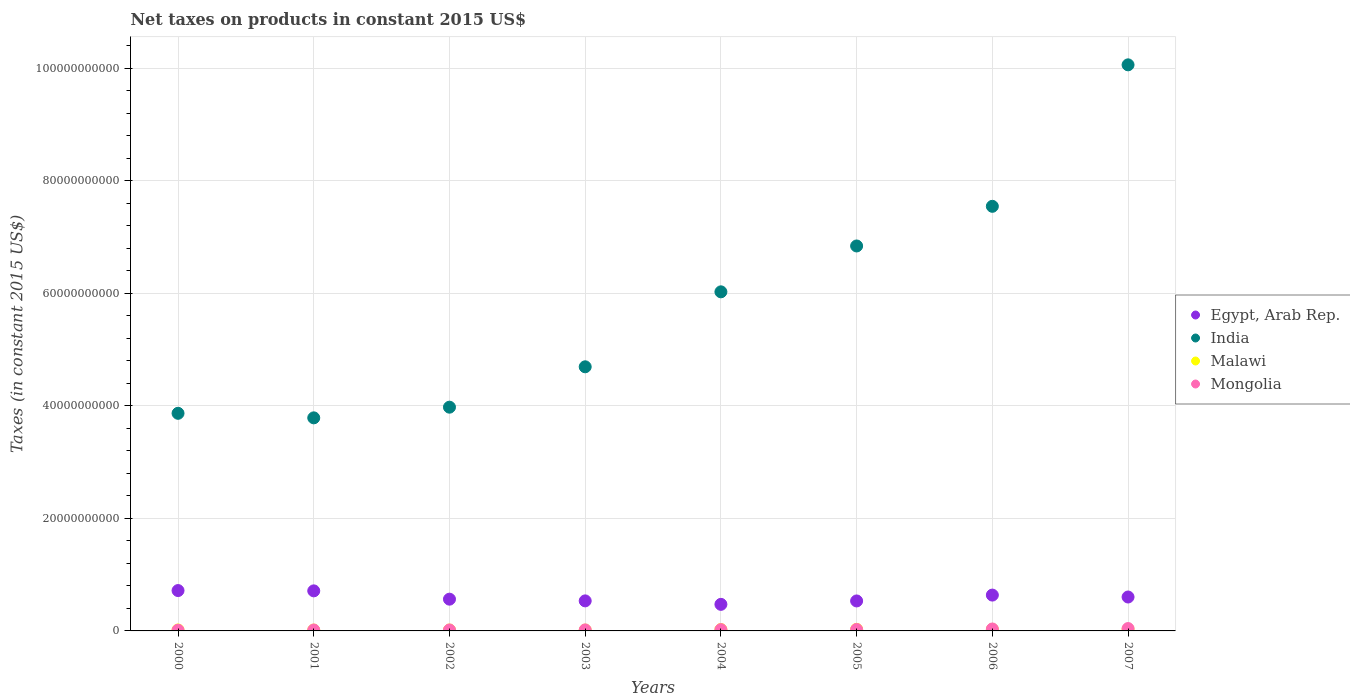How many different coloured dotlines are there?
Make the answer very short. 4. What is the net taxes on products in Malawi in 2005?
Make the answer very short. 2.83e+08. Across all years, what is the maximum net taxes on products in Malawi?
Offer a very short reply. 3.02e+08. Across all years, what is the minimum net taxes on products in Egypt, Arab Rep.?
Give a very brief answer. 4.72e+09. In which year was the net taxes on products in Egypt, Arab Rep. minimum?
Give a very brief answer. 2004. What is the total net taxes on products in Mongolia in the graph?
Give a very brief answer. 1.89e+09. What is the difference between the net taxes on products in Malawi in 2000 and that in 2001?
Make the answer very short. 1.61e+07. What is the difference between the net taxes on products in Egypt, Arab Rep. in 2003 and the net taxes on products in India in 2000?
Give a very brief answer. -3.33e+1. What is the average net taxes on products in Mongolia per year?
Make the answer very short. 2.36e+08. In the year 2002, what is the difference between the net taxes on products in Mongolia and net taxes on products in Malawi?
Provide a short and direct response. 6.00e+06. In how many years, is the net taxes on products in Mongolia greater than 60000000000 US$?
Your answer should be very brief. 0. What is the ratio of the net taxes on products in Mongolia in 2000 to that in 2007?
Give a very brief answer. 0.3. Is the net taxes on products in Mongolia in 2001 less than that in 2004?
Provide a succinct answer. Yes. What is the difference between the highest and the second highest net taxes on products in Mongolia?
Your response must be concise. 7.67e+07. What is the difference between the highest and the lowest net taxes on products in Malawi?
Make the answer very short. 1.51e+08. Is the sum of the net taxes on products in Malawi in 2002 and 2003 greater than the maximum net taxes on products in Egypt, Arab Rep. across all years?
Offer a terse response. No. Is it the case that in every year, the sum of the net taxes on products in India and net taxes on products in Malawi  is greater than the net taxes on products in Egypt, Arab Rep.?
Offer a very short reply. Yes. Does the net taxes on products in India monotonically increase over the years?
Provide a succinct answer. No. Does the graph contain grids?
Give a very brief answer. Yes. What is the title of the graph?
Provide a succinct answer. Net taxes on products in constant 2015 US$. Does "French Polynesia" appear as one of the legend labels in the graph?
Make the answer very short. No. What is the label or title of the Y-axis?
Your response must be concise. Taxes (in constant 2015 US$). What is the Taxes (in constant 2015 US$) of Egypt, Arab Rep. in 2000?
Keep it short and to the point. 7.17e+09. What is the Taxes (in constant 2015 US$) of India in 2000?
Your answer should be compact. 3.87e+1. What is the Taxes (in constant 2015 US$) of Malawi in 2000?
Provide a succinct answer. 1.71e+08. What is the Taxes (in constant 2015 US$) in Mongolia in 2000?
Your answer should be very brief. 1.27e+08. What is the Taxes (in constant 2015 US$) of Egypt, Arab Rep. in 2001?
Make the answer very short. 7.12e+09. What is the Taxes (in constant 2015 US$) in India in 2001?
Provide a succinct answer. 3.79e+1. What is the Taxes (in constant 2015 US$) of Malawi in 2001?
Ensure brevity in your answer.  1.55e+08. What is the Taxes (in constant 2015 US$) in Mongolia in 2001?
Give a very brief answer. 1.63e+08. What is the Taxes (in constant 2015 US$) in Egypt, Arab Rep. in 2002?
Your answer should be very brief. 5.64e+09. What is the Taxes (in constant 2015 US$) in India in 2002?
Make the answer very short. 3.98e+1. What is the Taxes (in constant 2015 US$) in Malawi in 2002?
Give a very brief answer. 1.62e+08. What is the Taxes (in constant 2015 US$) of Mongolia in 2002?
Offer a very short reply. 1.68e+08. What is the Taxes (in constant 2015 US$) in Egypt, Arab Rep. in 2003?
Offer a terse response. 5.34e+09. What is the Taxes (in constant 2015 US$) in India in 2003?
Give a very brief answer. 4.69e+1. What is the Taxes (in constant 2015 US$) in Malawi in 2003?
Provide a short and direct response. 1.52e+08. What is the Taxes (in constant 2015 US$) in Mongolia in 2003?
Provide a succinct answer. 1.78e+08. What is the Taxes (in constant 2015 US$) in Egypt, Arab Rep. in 2004?
Offer a very short reply. 4.72e+09. What is the Taxes (in constant 2015 US$) of India in 2004?
Give a very brief answer. 6.03e+1. What is the Taxes (in constant 2015 US$) of Malawi in 2004?
Ensure brevity in your answer.  2.44e+08. What is the Taxes (in constant 2015 US$) in Mongolia in 2004?
Make the answer very short. 2.27e+08. What is the Taxes (in constant 2015 US$) of Egypt, Arab Rep. in 2005?
Your response must be concise. 5.33e+09. What is the Taxes (in constant 2015 US$) of India in 2005?
Your answer should be compact. 6.84e+1. What is the Taxes (in constant 2015 US$) of Malawi in 2005?
Provide a succinct answer. 2.83e+08. What is the Taxes (in constant 2015 US$) of Mongolia in 2005?
Give a very brief answer. 2.59e+08. What is the Taxes (in constant 2015 US$) in Egypt, Arab Rep. in 2006?
Make the answer very short. 6.37e+09. What is the Taxes (in constant 2015 US$) of India in 2006?
Provide a succinct answer. 7.55e+1. What is the Taxes (in constant 2015 US$) of Malawi in 2006?
Your answer should be very brief. 2.82e+08. What is the Taxes (in constant 2015 US$) of Mongolia in 2006?
Your answer should be very brief. 3.44e+08. What is the Taxes (in constant 2015 US$) in Egypt, Arab Rep. in 2007?
Make the answer very short. 6.03e+09. What is the Taxes (in constant 2015 US$) in India in 2007?
Your response must be concise. 1.01e+11. What is the Taxes (in constant 2015 US$) in Malawi in 2007?
Offer a very short reply. 3.02e+08. What is the Taxes (in constant 2015 US$) in Mongolia in 2007?
Keep it short and to the point. 4.20e+08. Across all years, what is the maximum Taxes (in constant 2015 US$) of Egypt, Arab Rep.?
Your response must be concise. 7.17e+09. Across all years, what is the maximum Taxes (in constant 2015 US$) in India?
Provide a short and direct response. 1.01e+11. Across all years, what is the maximum Taxes (in constant 2015 US$) of Malawi?
Offer a very short reply. 3.02e+08. Across all years, what is the maximum Taxes (in constant 2015 US$) of Mongolia?
Offer a very short reply. 4.20e+08. Across all years, what is the minimum Taxes (in constant 2015 US$) in Egypt, Arab Rep.?
Keep it short and to the point. 4.72e+09. Across all years, what is the minimum Taxes (in constant 2015 US$) of India?
Provide a short and direct response. 3.79e+1. Across all years, what is the minimum Taxes (in constant 2015 US$) in Malawi?
Ensure brevity in your answer.  1.52e+08. Across all years, what is the minimum Taxes (in constant 2015 US$) in Mongolia?
Make the answer very short. 1.27e+08. What is the total Taxes (in constant 2015 US$) in Egypt, Arab Rep. in the graph?
Provide a succinct answer. 4.77e+1. What is the total Taxes (in constant 2015 US$) of India in the graph?
Provide a short and direct response. 4.68e+11. What is the total Taxes (in constant 2015 US$) of Malawi in the graph?
Your answer should be very brief. 1.75e+09. What is the total Taxes (in constant 2015 US$) of Mongolia in the graph?
Your answer should be very brief. 1.89e+09. What is the difference between the Taxes (in constant 2015 US$) in Egypt, Arab Rep. in 2000 and that in 2001?
Make the answer very short. 5.32e+07. What is the difference between the Taxes (in constant 2015 US$) in India in 2000 and that in 2001?
Make the answer very short. 8.07e+08. What is the difference between the Taxes (in constant 2015 US$) of Malawi in 2000 and that in 2001?
Keep it short and to the point. 1.61e+07. What is the difference between the Taxes (in constant 2015 US$) in Mongolia in 2000 and that in 2001?
Give a very brief answer. -3.56e+07. What is the difference between the Taxes (in constant 2015 US$) in Egypt, Arab Rep. in 2000 and that in 2002?
Your answer should be compact. 1.53e+09. What is the difference between the Taxes (in constant 2015 US$) of India in 2000 and that in 2002?
Offer a very short reply. -1.09e+09. What is the difference between the Taxes (in constant 2015 US$) of Malawi in 2000 and that in 2002?
Your answer should be compact. 9.42e+06. What is the difference between the Taxes (in constant 2015 US$) of Mongolia in 2000 and that in 2002?
Provide a short and direct response. -4.05e+07. What is the difference between the Taxes (in constant 2015 US$) in Egypt, Arab Rep. in 2000 and that in 2003?
Your answer should be very brief. 1.83e+09. What is the difference between the Taxes (in constant 2015 US$) in India in 2000 and that in 2003?
Ensure brevity in your answer.  -8.27e+09. What is the difference between the Taxes (in constant 2015 US$) in Malawi in 2000 and that in 2003?
Offer a very short reply. 1.94e+07. What is the difference between the Taxes (in constant 2015 US$) of Mongolia in 2000 and that in 2003?
Provide a succinct answer. -5.13e+07. What is the difference between the Taxes (in constant 2015 US$) in Egypt, Arab Rep. in 2000 and that in 2004?
Your response must be concise. 2.45e+09. What is the difference between the Taxes (in constant 2015 US$) of India in 2000 and that in 2004?
Provide a short and direct response. -2.16e+1. What is the difference between the Taxes (in constant 2015 US$) in Malawi in 2000 and that in 2004?
Make the answer very short. -7.26e+07. What is the difference between the Taxes (in constant 2015 US$) of Mongolia in 2000 and that in 2004?
Your answer should be compact. -1.00e+08. What is the difference between the Taxes (in constant 2015 US$) of Egypt, Arab Rep. in 2000 and that in 2005?
Provide a short and direct response. 1.84e+09. What is the difference between the Taxes (in constant 2015 US$) in India in 2000 and that in 2005?
Make the answer very short. -2.97e+1. What is the difference between the Taxes (in constant 2015 US$) in Malawi in 2000 and that in 2005?
Your response must be concise. -1.12e+08. What is the difference between the Taxes (in constant 2015 US$) of Mongolia in 2000 and that in 2005?
Keep it short and to the point. -1.32e+08. What is the difference between the Taxes (in constant 2015 US$) in Egypt, Arab Rep. in 2000 and that in 2006?
Ensure brevity in your answer.  8.04e+08. What is the difference between the Taxes (in constant 2015 US$) in India in 2000 and that in 2006?
Offer a terse response. -3.68e+1. What is the difference between the Taxes (in constant 2015 US$) in Malawi in 2000 and that in 2006?
Your answer should be very brief. -1.11e+08. What is the difference between the Taxes (in constant 2015 US$) in Mongolia in 2000 and that in 2006?
Make the answer very short. -2.16e+08. What is the difference between the Taxes (in constant 2015 US$) of Egypt, Arab Rep. in 2000 and that in 2007?
Your answer should be very brief. 1.15e+09. What is the difference between the Taxes (in constant 2015 US$) in India in 2000 and that in 2007?
Offer a terse response. -6.19e+1. What is the difference between the Taxes (in constant 2015 US$) of Malawi in 2000 and that in 2007?
Your response must be concise. -1.31e+08. What is the difference between the Taxes (in constant 2015 US$) of Mongolia in 2000 and that in 2007?
Your response must be concise. -2.93e+08. What is the difference between the Taxes (in constant 2015 US$) in Egypt, Arab Rep. in 2001 and that in 2002?
Offer a very short reply. 1.48e+09. What is the difference between the Taxes (in constant 2015 US$) in India in 2001 and that in 2002?
Your response must be concise. -1.90e+09. What is the difference between the Taxes (in constant 2015 US$) of Malawi in 2001 and that in 2002?
Make the answer very short. -6.73e+06. What is the difference between the Taxes (in constant 2015 US$) of Mongolia in 2001 and that in 2002?
Keep it short and to the point. -4.89e+06. What is the difference between the Taxes (in constant 2015 US$) of Egypt, Arab Rep. in 2001 and that in 2003?
Your answer should be compact. 1.78e+09. What is the difference between the Taxes (in constant 2015 US$) in India in 2001 and that in 2003?
Ensure brevity in your answer.  -9.07e+09. What is the difference between the Taxes (in constant 2015 US$) of Malawi in 2001 and that in 2003?
Provide a short and direct response. 3.26e+06. What is the difference between the Taxes (in constant 2015 US$) of Mongolia in 2001 and that in 2003?
Make the answer very short. -1.57e+07. What is the difference between the Taxes (in constant 2015 US$) of Egypt, Arab Rep. in 2001 and that in 2004?
Provide a short and direct response. 2.40e+09. What is the difference between the Taxes (in constant 2015 US$) in India in 2001 and that in 2004?
Your answer should be compact. -2.24e+1. What is the difference between the Taxes (in constant 2015 US$) in Malawi in 2001 and that in 2004?
Your answer should be very brief. -8.88e+07. What is the difference between the Taxes (in constant 2015 US$) in Mongolia in 2001 and that in 2004?
Your answer should be compact. -6.44e+07. What is the difference between the Taxes (in constant 2015 US$) in Egypt, Arab Rep. in 2001 and that in 2005?
Keep it short and to the point. 1.79e+09. What is the difference between the Taxes (in constant 2015 US$) of India in 2001 and that in 2005?
Provide a succinct answer. -3.05e+1. What is the difference between the Taxes (in constant 2015 US$) in Malawi in 2001 and that in 2005?
Keep it short and to the point. -1.28e+08. What is the difference between the Taxes (in constant 2015 US$) of Mongolia in 2001 and that in 2005?
Offer a terse response. -9.59e+07. What is the difference between the Taxes (in constant 2015 US$) of Egypt, Arab Rep. in 2001 and that in 2006?
Ensure brevity in your answer.  7.51e+08. What is the difference between the Taxes (in constant 2015 US$) in India in 2001 and that in 2006?
Your response must be concise. -3.76e+1. What is the difference between the Taxes (in constant 2015 US$) of Malawi in 2001 and that in 2006?
Your response must be concise. -1.27e+08. What is the difference between the Taxes (in constant 2015 US$) in Mongolia in 2001 and that in 2006?
Make the answer very short. -1.81e+08. What is the difference between the Taxes (in constant 2015 US$) of Egypt, Arab Rep. in 2001 and that in 2007?
Your response must be concise. 1.09e+09. What is the difference between the Taxes (in constant 2015 US$) in India in 2001 and that in 2007?
Make the answer very short. -6.27e+1. What is the difference between the Taxes (in constant 2015 US$) in Malawi in 2001 and that in 2007?
Provide a short and direct response. -1.47e+08. What is the difference between the Taxes (in constant 2015 US$) in Mongolia in 2001 and that in 2007?
Your answer should be very brief. -2.58e+08. What is the difference between the Taxes (in constant 2015 US$) of Egypt, Arab Rep. in 2002 and that in 2003?
Provide a short and direct response. 3.03e+08. What is the difference between the Taxes (in constant 2015 US$) in India in 2002 and that in 2003?
Ensure brevity in your answer.  -7.18e+09. What is the difference between the Taxes (in constant 2015 US$) in Malawi in 2002 and that in 2003?
Provide a short and direct response. 9.99e+06. What is the difference between the Taxes (in constant 2015 US$) in Mongolia in 2002 and that in 2003?
Provide a succinct answer. -1.08e+07. What is the difference between the Taxes (in constant 2015 US$) of Egypt, Arab Rep. in 2002 and that in 2004?
Your answer should be very brief. 9.22e+08. What is the difference between the Taxes (in constant 2015 US$) in India in 2002 and that in 2004?
Your answer should be very brief. -2.05e+1. What is the difference between the Taxes (in constant 2015 US$) in Malawi in 2002 and that in 2004?
Provide a succinct answer. -8.21e+07. What is the difference between the Taxes (in constant 2015 US$) in Mongolia in 2002 and that in 2004?
Your answer should be compact. -5.95e+07. What is the difference between the Taxes (in constant 2015 US$) in Egypt, Arab Rep. in 2002 and that in 2005?
Your response must be concise. 3.15e+08. What is the difference between the Taxes (in constant 2015 US$) in India in 2002 and that in 2005?
Keep it short and to the point. -2.86e+1. What is the difference between the Taxes (in constant 2015 US$) of Malawi in 2002 and that in 2005?
Ensure brevity in your answer.  -1.21e+08. What is the difference between the Taxes (in constant 2015 US$) in Mongolia in 2002 and that in 2005?
Give a very brief answer. -9.10e+07. What is the difference between the Taxes (in constant 2015 US$) of Egypt, Arab Rep. in 2002 and that in 2006?
Make the answer very short. -7.26e+08. What is the difference between the Taxes (in constant 2015 US$) of India in 2002 and that in 2006?
Keep it short and to the point. -3.57e+1. What is the difference between the Taxes (in constant 2015 US$) of Malawi in 2002 and that in 2006?
Make the answer very short. -1.20e+08. What is the difference between the Taxes (in constant 2015 US$) of Mongolia in 2002 and that in 2006?
Make the answer very short. -1.76e+08. What is the difference between the Taxes (in constant 2015 US$) of Egypt, Arab Rep. in 2002 and that in 2007?
Offer a very short reply. -3.84e+08. What is the difference between the Taxes (in constant 2015 US$) in India in 2002 and that in 2007?
Your answer should be compact. -6.08e+1. What is the difference between the Taxes (in constant 2015 US$) in Malawi in 2002 and that in 2007?
Give a very brief answer. -1.41e+08. What is the difference between the Taxes (in constant 2015 US$) of Mongolia in 2002 and that in 2007?
Ensure brevity in your answer.  -2.53e+08. What is the difference between the Taxes (in constant 2015 US$) of Egypt, Arab Rep. in 2003 and that in 2004?
Your answer should be very brief. 6.19e+08. What is the difference between the Taxes (in constant 2015 US$) of India in 2003 and that in 2004?
Offer a terse response. -1.33e+1. What is the difference between the Taxes (in constant 2015 US$) in Malawi in 2003 and that in 2004?
Your answer should be compact. -9.20e+07. What is the difference between the Taxes (in constant 2015 US$) of Mongolia in 2003 and that in 2004?
Ensure brevity in your answer.  -4.87e+07. What is the difference between the Taxes (in constant 2015 US$) in Egypt, Arab Rep. in 2003 and that in 2005?
Make the answer very short. 1.14e+07. What is the difference between the Taxes (in constant 2015 US$) of India in 2003 and that in 2005?
Provide a succinct answer. -2.15e+1. What is the difference between the Taxes (in constant 2015 US$) of Malawi in 2003 and that in 2005?
Keep it short and to the point. -1.31e+08. What is the difference between the Taxes (in constant 2015 US$) in Mongolia in 2003 and that in 2005?
Provide a short and direct response. -8.02e+07. What is the difference between the Taxes (in constant 2015 US$) of Egypt, Arab Rep. in 2003 and that in 2006?
Make the answer very short. -1.03e+09. What is the difference between the Taxes (in constant 2015 US$) of India in 2003 and that in 2006?
Offer a very short reply. -2.85e+1. What is the difference between the Taxes (in constant 2015 US$) of Malawi in 2003 and that in 2006?
Provide a short and direct response. -1.30e+08. What is the difference between the Taxes (in constant 2015 US$) in Mongolia in 2003 and that in 2006?
Ensure brevity in your answer.  -1.65e+08. What is the difference between the Taxes (in constant 2015 US$) of Egypt, Arab Rep. in 2003 and that in 2007?
Your response must be concise. -6.87e+08. What is the difference between the Taxes (in constant 2015 US$) in India in 2003 and that in 2007?
Your answer should be compact. -5.37e+1. What is the difference between the Taxes (in constant 2015 US$) of Malawi in 2003 and that in 2007?
Provide a succinct answer. -1.51e+08. What is the difference between the Taxes (in constant 2015 US$) of Mongolia in 2003 and that in 2007?
Your answer should be compact. -2.42e+08. What is the difference between the Taxes (in constant 2015 US$) of Egypt, Arab Rep. in 2004 and that in 2005?
Ensure brevity in your answer.  -6.07e+08. What is the difference between the Taxes (in constant 2015 US$) in India in 2004 and that in 2005?
Make the answer very short. -8.15e+09. What is the difference between the Taxes (in constant 2015 US$) of Malawi in 2004 and that in 2005?
Give a very brief answer. -3.90e+07. What is the difference between the Taxes (in constant 2015 US$) in Mongolia in 2004 and that in 2005?
Provide a short and direct response. -3.15e+07. What is the difference between the Taxes (in constant 2015 US$) in Egypt, Arab Rep. in 2004 and that in 2006?
Your answer should be compact. -1.65e+09. What is the difference between the Taxes (in constant 2015 US$) in India in 2004 and that in 2006?
Give a very brief answer. -1.52e+1. What is the difference between the Taxes (in constant 2015 US$) in Malawi in 2004 and that in 2006?
Provide a short and direct response. -3.80e+07. What is the difference between the Taxes (in constant 2015 US$) of Mongolia in 2004 and that in 2006?
Ensure brevity in your answer.  -1.16e+08. What is the difference between the Taxes (in constant 2015 US$) of Egypt, Arab Rep. in 2004 and that in 2007?
Offer a terse response. -1.31e+09. What is the difference between the Taxes (in constant 2015 US$) in India in 2004 and that in 2007?
Provide a succinct answer. -4.03e+1. What is the difference between the Taxes (in constant 2015 US$) in Malawi in 2004 and that in 2007?
Give a very brief answer. -5.85e+07. What is the difference between the Taxes (in constant 2015 US$) of Mongolia in 2004 and that in 2007?
Your answer should be very brief. -1.93e+08. What is the difference between the Taxes (in constant 2015 US$) of Egypt, Arab Rep. in 2005 and that in 2006?
Ensure brevity in your answer.  -1.04e+09. What is the difference between the Taxes (in constant 2015 US$) in India in 2005 and that in 2006?
Your answer should be compact. -7.05e+09. What is the difference between the Taxes (in constant 2015 US$) of Malawi in 2005 and that in 2006?
Offer a very short reply. 1.02e+06. What is the difference between the Taxes (in constant 2015 US$) of Mongolia in 2005 and that in 2006?
Your response must be concise. -8.49e+07. What is the difference between the Taxes (in constant 2015 US$) in Egypt, Arab Rep. in 2005 and that in 2007?
Provide a short and direct response. -6.99e+08. What is the difference between the Taxes (in constant 2015 US$) of India in 2005 and that in 2007?
Make the answer very short. -3.22e+1. What is the difference between the Taxes (in constant 2015 US$) in Malawi in 2005 and that in 2007?
Offer a very short reply. -1.95e+07. What is the difference between the Taxes (in constant 2015 US$) in Mongolia in 2005 and that in 2007?
Offer a very short reply. -1.62e+08. What is the difference between the Taxes (in constant 2015 US$) of Egypt, Arab Rep. in 2006 and that in 2007?
Your response must be concise. 3.42e+08. What is the difference between the Taxes (in constant 2015 US$) of India in 2006 and that in 2007?
Offer a very short reply. -2.51e+1. What is the difference between the Taxes (in constant 2015 US$) in Malawi in 2006 and that in 2007?
Your answer should be compact. -2.05e+07. What is the difference between the Taxes (in constant 2015 US$) of Mongolia in 2006 and that in 2007?
Make the answer very short. -7.67e+07. What is the difference between the Taxes (in constant 2015 US$) in Egypt, Arab Rep. in 2000 and the Taxes (in constant 2015 US$) in India in 2001?
Make the answer very short. -3.07e+1. What is the difference between the Taxes (in constant 2015 US$) in Egypt, Arab Rep. in 2000 and the Taxes (in constant 2015 US$) in Malawi in 2001?
Give a very brief answer. 7.02e+09. What is the difference between the Taxes (in constant 2015 US$) of Egypt, Arab Rep. in 2000 and the Taxes (in constant 2015 US$) of Mongolia in 2001?
Provide a short and direct response. 7.01e+09. What is the difference between the Taxes (in constant 2015 US$) of India in 2000 and the Taxes (in constant 2015 US$) of Malawi in 2001?
Offer a terse response. 3.85e+1. What is the difference between the Taxes (in constant 2015 US$) of India in 2000 and the Taxes (in constant 2015 US$) of Mongolia in 2001?
Your answer should be very brief. 3.85e+1. What is the difference between the Taxes (in constant 2015 US$) of Malawi in 2000 and the Taxes (in constant 2015 US$) of Mongolia in 2001?
Your answer should be very brief. 8.31e+06. What is the difference between the Taxes (in constant 2015 US$) in Egypt, Arab Rep. in 2000 and the Taxes (in constant 2015 US$) in India in 2002?
Give a very brief answer. -3.26e+1. What is the difference between the Taxes (in constant 2015 US$) of Egypt, Arab Rep. in 2000 and the Taxes (in constant 2015 US$) of Malawi in 2002?
Provide a succinct answer. 7.01e+09. What is the difference between the Taxes (in constant 2015 US$) in Egypt, Arab Rep. in 2000 and the Taxes (in constant 2015 US$) in Mongolia in 2002?
Give a very brief answer. 7.00e+09. What is the difference between the Taxes (in constant 2015 US$) of India in 2000 and the Taxes (in constant 2015 US$) of Malawi in 2002?
Offer a terse response. 3.85e+1. What is the difference between the Taxes (in constant 2015 US$) in India in 2000 and the Taxes (in constant 2015 US$) in Mongolia in 2002?
Provide a succinct answer. 3.85e+1. What is the difference between the Taxes (in constant 2015 US$) of Malawi in 2000 and the Taxes (in constant 2015 US$) of Mongolia in 2002?
Your answer should be compact. 3.42e+06. What is the difference between the Taxes (in constant 2015 US$) of Egypt, Arab Rep. in 2000 and the Taxes (in constant 2015 US$) of India in 2003?
Make the answer very short. -3.98e+1. What is the difference between the Taxes (in constant 2015 US$) of Egypt, Arab Rep. in 2000 and the Taxes (in constant 2015 US$) of Malawi in 2003?
Provide a succinct answer. 7.02e+09. What is the difference between the Taxes (in constant 2015 US$) in Egypt, Arab Rep. in 2000 and the Taxes (in constant 2015 US$) in Mongolia in 2003?
Ensure brevity in your answer.  6.99e+09. What is the difference between the Taxes (in constant 2015 US$) of India in 2000 and the Taxes (in constant 2015 US$) of Malawi in 2003?
Your answer should be very brief. 3.85e+1. What is the difference between the Taxes (in constant 2015 US$) of India in 2000 and the Taxes (in constant 2015 US$) of Mongolia in 2003?
Make the answer very short. 3.85e+1. What is the difference between the Taxes (in constant 2015 US$) of Malawi in 2000 and the Taxes (in constant 2015 US$) of Mongolia in 2003?
Make the answer very short. -7.42e+06. What is the difference between the Taxes (in constant 2015 US$) of Egypt, Arab Rep. in 2000 and the Taxes (in constant 2015 US$) of India in 2004?
Offer a terse response. -5.31e+1. What is the difference between the Taxes (in constant 2015 US$) in Egypt, Arab Rep. in 2000 and the Taxes (in constant 2015 US$) in Malawi in 2004?
Ensure brevity in your answer.  6.93e+09. What is the difference between the Taxes (in constant 2015 US$) in Egypt, Arab Rep. in 2000 and the Taxes (in constant 2015 US$) in Mongolia in 2004?
Provide a succinct answer. 6.95e+09. What is the difference between the Taxes (in constant 2015 US$) in India in 2000 and the Taxes (in constant 2015 US$) in Malawi in 2004?
Make the answer very short. 3.84e+1. What is the difference between the Taxes (in constant 2015 US$) of India in 2000 and the Taxes (in constant 2015 US$) of Mongolia in 2004?
Provide a succinct answer. 3.84e+1. What is the difference between the Taxes (in constant 2015 US$) of Malawi in 2000 and the Taxes (in constant 2015 US$) of Mongolia in 2004?
Keep it short and to the point. -5.61e+07. What is the difference between the Taxes (in constant 2015 US$) in Egypt, Arab Rep. in 2000 and the Taxes (in constant 2015 US$) in India in 2005?
Keep it short and to the point. -6.12e+1. What is the difference between the Taxes (in constant 2015 US$) in Egypt, Arab Rep. in 2000 and the Taxes (in constant 2015 US$) in Malawi in 2005?
Offer a terse response. 6.89e+09. What is the difference between the Taxes (in constant 2015 US$) of Egypt, Arab Rep. in 2000 and the Taxes (in constant 2015 US$) of Mongolia in 2005?
Your answer should be compact. 6.91e+09. What is the difference between the Taxes (in constant 2015 US$) in India in 2000 and the Taxes (in constant 2015 US$) in Malawi in 2005?
Your answer should be compact. 3.84e+1. What is the difference between the Taxes (in constant 2015 US$) of India in 2000 and the Taxes (in constant 2015 US$) of Mongolia in 2005?
Offer a very short reply. 3.84e+1. What is the difference between the Taxes (in constant 2015 US$) of Malawi in 2000 and the Taxes (in constant 2015 US$) of Mongolia in 2005?
Your answer should be compact. -8.76e+07. What is the difference between the Taxes (in constant 2015 US$) in Egypt, Arab Rep. in 2000 and the Taxes (in constant 2015 US$) in India in 2006?
Your response must be concise. -6.83e+1. What is the difference between the Taxes (in constant 2015 US$) of Egypt, Arab Rep. in 2000 and the Taxes (in constant 2015 US$) of Malawi in 2006?
Your answer should be very brief. 6.89e+09. What is the difference between the Taxes (in constant 2015 US$) in Egypt, Arab Rep. in 2000 and the Taxes (in constant 2015 US$) in Mongolia in 2006?
Offer a terse response. 6.83e+09. What is the difference between the Taxes (in constant 2015 US$) in India in 2000 and the Taxes (in constant 2015 US$) in Malawi in 2006?
Keep it short and to the point. 3.84e+1. What is the difference between the Taxes (in constant 2015 US$) in India in 2000 and the Taxes (in constant 2015 US$) in Mongolia in 2006?
Keep it short and to the point. 3.83e+1. What is the difference between the Taxes (in constant 2015 US$) in Malawi in 2000 and the Taxes (in constant 2015 US$) in Mongolia in 2006?
Provide a short and direct response. -1.72e+08. What is the difference between the Taxes (in constant 2015 US$) in Egypt, Arab Rep. in 2000 and the Taxes (in constant 2015 US$) in India in 2007?
Offer a very short reply. -9.34e+1. What is the difference between the Taxes (in constant 2015 US$) in Egypt, Arab Rep. in 2000 and the Taxes (in constant 2015 US$) in Malawi in 2007?
Give a very brief answer. 6.87e+09. What is the difference between the Taxes (in constant 2015 US$) in Egypt, Arab Rep. in 2000 and the Taxes (in constant 2015 US$) in Mongolia in 2007?
Your response must be concise. 6.75e+09. What is the difference between the Taxes (in constant 2015 US$) of India in 2000 and the Taxes (in constant 2015 US$) of Malawi in 2007?
Provide a succinct answer. 3.84e+1. What is the difference between the Taxes (in constant 2015 US$) in India in 2000 and the Taxes (in constant 2015 US$) in Mongolia in 2007?
Provide a short and direct response. 3.83e+1. What is the difference between the Taxes (in constant 2015 US$) in Malawi in 2000 and the Taxes (in constant 2015 US$) in Mongolia in 2007?
Make the answer very short. -2.49e+08. What is the difference between the Taxes (in constant 2015 US$) of Egypt, Arab Rep. in 2001 and the Taxes (in constant 2015 US$) of India in 2002?
Keep it short and to the point. -3.26e+1. What is the difference between the Taxes (in constant 2015 US$) in Egypt, Arab Rep. in 2001 and the Taxes (in constant 2015 US$) in Malawi in 2002?
Keep it short and to the point. 6.96e+09. What is the difference between the Taxes (in constant 2015 US$) in Egypt, Arab Rep. in 2001 and the Taxes (in constant 2015 US$) in Mongolia in 2002?
Your answer should be very brief. 6.95e+09. What is the difference between the Taxes (in constant 2015 US$) in India in 2001 and the Taxes (in constant 2015 US$) in Malawi in 2002?
Your answer should be compact. 3.77e+1. What is the difference between the Taxes (in constant 2015 US$) of India in 2001 and the Taxes (in constant 2015 US$) of Mongolia in 2002?
Give a very brief answer. 3.77e+1. What is the difference between the Taxes (in constant 2015 US$) in Malawi in 2001 and the Taxes (in constant 2015 US$) in Mongolia in 2002?
Make the answer very short. -1.27e+07. What is the difference between the Taxes (in constant 2015 US$) of Egypt, Arab Rep. in 2001 and the Taxes (in constant 2015 US$) of India in 2003?
Your answer should be compact. -3.98e+1. What is the difference between the Taxes (in constant 2015 US$) in Egypt, Arab Rep. in 2001 and the Taxes (in constant 2015 US$) in Malawi in 2003?
Your answer should be very brief. 6.97e+09. What is the difference between the Taxes (in constant 2015 US$) in Egypt, Arab Rep. in 2001 and the Taxes (in constant 2015 US$) in Mongolia in 2003?
Provide a short and direct response. 6.94e+09. What is the difference between the Taxes (in constant 2015 US$) of India in 2001 and the Taxes (in constant 2015 US$) of Malawi in 2003?
Provide a succinct answer. 3.77e+1. What is the difference between the Taxes (in constant 2015 US$) of India in 2001 and the Taxes (in constant 2015 US$) of Mongolia in 2003?
Offer a very short reply. 3.77e+1. What is the difference between the Taxes (in constant 2015 US$) of Malawi in 2001 and the Taxes (in constant 2015 US$) of Mongolia in 2003?
Provide a succinct answer. -2.36e+07. What is the difference between the Taxes (in constant 2015 US$) in Egypt, Arab Rep. in 2001 and the Taxes (in constant 2015 US$) in India in 2004?
Offer a terse response. -5.31e+1. What is the difference between the Taxes (in constant 2015 US$) of Egypt, Arab Rep. in 2001 and the Taxes (in constant 2015 US$) of Malawi in 2004?
Provide a succinct answer. 6.88e+09. What is the difference between the Taxes (in constant 2015 US$) of Egypt, Arab Rep. in 2001 and the Taxes (in constant 2015 US$) of Mongolia in 2004?
Your response must be concise. 6.89e+09. What is the difference between the Taxes (in constant 2015 US$) of India in 2001 and the Taxes (in constant 2015 US$) of Malawi in 2004?
Offer a terse response. 3.76e+1. What is the difference between the Taxes (in constant 2015 US$) of India in 2001 and the Taxes (in constant 2015 US$) of Mongolia in 2004?
Give a very brief answer. 3.76e+1. What is the difference between the Taxes (in constant 2015 US$) of Malawi in 2001 and the Taxes (in constant 2015 US$) of Mongolia in 2004?
Provide a short and direct response. -7.22e+07. What is the difference between the Taxes (in constant 2015 US$) of Egypt, Arab Rep. in 2001 and the Taxes (in constant 2015 US$) of India in 2005?
Your response must be concise. -6.13e+1. What is the difference between the Taxes (in constant 2015 US$) of Egypt, Arab Rep. in 2001 and the Taxes (in constant 2015 US$) of Malawi in 2005?
Offer a very short reply. 6.84e+09. What is the difference between the Taxes (in constant 2015 US$) of Egypt, Arab Rep. in 2001 and the Taxes (in constant 2015 US$) of Mongolia in 2005?
Provide a short and direct response. 6.86e+09. What is the difference between the Taxes (in constant 2015 US$) in India in 2001 and the Taxes (in constant 2015 US$) in Malawi in 2005?
Ensure brevity in your answer.  3.76e+1. What is the difference between the Taxes (in constant 2015 US$) in India in 2001 and the Taxes (in constant 2015 US$) in Mongolia in 2005?
Your response must be concise. 3.76e+1. What is the difference between the Taxes (in constant 2015 US$) of Malawi in 2001 and the Taxes (in constant 2015 US$) of Mongolia in 2005?
Provide a succinct answer. -1.04e+08. What is the difference between the Taxes (in constant 2015 US$) of Egypt, Arab Rep. in 2001 and the Taxes (in constant 2015 US$) of India in 2006?
Ensure brevity in your answer.  -6.83e+1. What is the difference between the Taxes (in constant 2015 US$) of Egypt, Arab Rep. in 2001 and the Taxes (in constant 2015 US$) of Malawi in 2006?
Give a very brief answer. 6.84e+09. What is the difference between the Taxes (in constant 2015 US$) in Egypt, Arab Rep. in 2001 and the Taxes (in constant 2015 US$) in Mongolia in 2006?
Your answer should be very brief. 6.78e+09. What is the difference between the Taxes (in constant 2015 US$) in India in 2001 and the Taxes (in constant 2015 US$) in Malawi in 2006?
Make the answer very short. 3.76e+1. What is the difference between the Taxes (in constant 2015 US$) of India in 2001 and the Taxes (in constant 2015 US$) of Mongolia in 2006?
Offer a terse response. 3.75e+1. What is the difference between the Taxes (in constant 2015 US$) in Malawi in 2001 and the Taxes (in constant 2015 US$) in Mongolia in 2006?
Make the answer very short. -1.89e+08. What is the difference between the Taxes (in constant 2015 US$) in Egypt, Arab Rep. in 2001 and the Taxes (in constant 2015 US$) in India in 2007?
Provide a succinct answer. -9.35e+1. What is the difference between the Taxes (in constant 2015 US$) in Egypt, Arab Rep. in 2001 and the Taxes (in constant 2015 US$) in Malawi in 2007?
Your response must be concise. 6.82e+09. What is the difference between the Taxes (in constant 2015 US$) of Egypt, Arab Rep. in 2001 and the Taxes (in constant 2015 US$) of Mongolia in 2007?
Make the answer very short. 6.70e+09. What is the difference between the Taxes (in constant 2015 US$) of India in 2001 and the Taxes (in constant 2015 US$) of Malawi in 2007?
Offer a terse response. 3.76e+1. What is the difference between the Taxes (in constant 2015 US$) in India in 2001 and the Taxes (in constant 2015 US$) in Mongolia in 2007?
Keep it short and to the point. 3.74e+1. What is the difference between the Taxes (in constant 2015 US$) in Malawi in 2001 and the Taxes (in constant 2015 US$) in Mongolia in 2007?
Keep it short and to the point. -2.65e+08. What is the difference between the Taxes (in constant 2015 US$) in Egypt, Arab Rep. in 2002 and the Taxes (in constant 2015 US$) in India in 2003?
Your response must be concise. -4.13e+1. What is the difference between the Taxes (in constant 2015 US$) in Egypt, Arab Rep. in 2002 and the Taxes (in constant 2015 US$) in Malawi in 2003?
Your answer should be compact. 5.49e+09. What is the difference between the Taxes (in constant 2015 US$) in Egypt, Arab Rep. in 2002 and the Taxes (in constant 2015 US$) in Mongolia in 2003?
Ensure brevity in your answer.  5.46e+09. What is the difference between the Taxes (in constant 2015 US$) of India in 2002 and the Taxes (in constant 2015 US$) of Malawi in 2003?
Your answer should be very brief. 3.96e+1. What is the difference between the Taxes (in constant 2015 US$) in India in 2002 and the Taxes (in constant 2015 US$) in Mongolia in 2003?
Keep it short and to the point. 3.96e+1. What is the difference between the Taxes (in constant 2015 US$) in Malawi in 2002 and the Taxes (in constant 2015 US$) in Mongolia in 2003?
Ensure brevity in your answer.  -1.68e+07. What is the difference between the Taxes (in constant 2015 US$) of Egypt, Arab Rep. in 2002 and the Taxes (in constant 2015 US$) of India in 2004?
Ensure brevity in your answer.  -5.46e+1. What is the difference between the Taxes (in constant 2015 US$) of Egypt, Arab Rep. in 2002 and the Taxes (in constant 2015 US$) of Malawi in 2004?
Offer a very short reply. 5.40e+09. What is the difference between the Taxes (in constant 2015 US$) in Egypt, Arab Rep. in 2002 and the Taxes (in constant 2015 US$) in Mongolia in 2004?
Provide a succinct answer. 5.42e+09. What is the difference between the Taxes (in constant 2015 US$) in India in 2002 and the Taxes (in constant 2015 US$) in Malawi in 2004?
Your answer should be compact. 3.95e+1. What is the difference between the Taxes (in constant 2015 US$) of India in 2002 and the Taxes (in constant 2015 US$) of Mongolia in 2004?
Offer a very short reply. 3.95e+1. What is the difference between the Taxes (in constant 2015 US$) of Malawi in 2002 and the Taxes (in constant 2015 US$) of Mongolia in 2004?
Offer a very short reply. -6.55e+07. What is the difference between the Taxes (in constant 2015 US$) in Egypt, Arab Rep. in 2002 and the Taxes (in constant 2015 US$) in India in 2005?
Provide a short and direct response. -6.28e+1. What is the difference between the Taxes (in constant 2015 US$) of Egypt, Arab Rep. in 2002 and the Taxes (in constant 2015 US$) of Malawi in 2005?
Keep it short and to the point. 5.36e+09. What is the difference between the Taxes (in constant 2015 US$) in Egypt, Arab Rep. in 2002 and the Taxes (in constant 2015 US$) in Mongolia in 2005?
Provide a short and direct response. 5.38e+09. What is the difference between the Taxes (in constant 2015 US$) of India in 2002 and the Taxes (in constant 2015 US$) of Malawi in 2005?
Offer a terse response. 3.95e+1. What is the difference between the Taxes (in constant 2015 US$) of India in 2002 and the Taxes (in constant 2015 US$) of Mongolia in 2005?
Provide a succinct answer. 3.95e+1. What is the difference between the Taxes (in constant 2015 US$) of Malawi in 2002 and the Taxes (in constant 2015 US$) of Mongolia in 2005?
Provide a succinct answer. -9.70e+07. What is the difference between the Taxes (in constant 2015 US$) of Egypt, Arab Rep. in 2002 and the Taxes (in constant 2015 US$) of India in 2006?
Your answer should be very brief. -6.98e+1. What is the difference between the Taxes (in constant 2015 US$) of Egypt, Arab Rep. in 2002 and the Taxes (in constant 2015 US$) of Malawi in 2006?
Offer a terse response. 5.36e+09. What is the difference between the Taxes (in constant 2015 US$) of Egypt, Arab Rep. in 2002 and the Taxes (in constant 2015 US$) of Mongolia in 2006?
Keep it short and to the point. 5.30e+09. What is the difference between the Taxes (in constant 2015 US$) in India in 2002 and the Taxes (in constant 2015 US$) in Malawi in 2006?
Your response must be concise. 3.95e+1. What is the difference between the Taxes (in constant 2015 US$) of India in 2002 and the Taxes (in constant 2015 US$) of Mongolia in 2006?
Make the answer very short. 3.94e+1. What is the difference between the Taxes (in constant 2015 US$) in Malawi in 2002 and the Taxes (in constant 2015 US$) in Mongolia in 2006?
Your answer should be very brief. -1.82e+08. What is the difference between the Taxes (in constant 2015 US$) in Egypt, Arab Rep. in 2002 and the Taxes (in constant 2015 US$) in India in 2007?
Offer a very short reply. -9.50e+1. What is the difference between the Taxes (in constant 2015 US$) in Egypt, Arab Rep. in 2002 and the Taxes (in constant 2015 US$) in Malawi in 2007?
Make the answer very short. 5.34e+09. What is the difference between the Taxes (in constant 2015 US$) in Egypt, Arab Rep. in 2002 and the Taxes (in constant 2015 US$) in Mongolia in 2007?
Offer a very short reply. 5.22e+09. What is the difference between the Taxes (in constant 2015 US$) in India in 2002 and the Taxes (in constant 2015 US$) in Malawi in 2007?
Give a very brief answer. 3.95e+1. What is the difference between the Taxes (in constant 2015 US$) in India in 2002 and the Taxes (in constant 2015 US$) in Mongolia in 2007?
Provide a succinct answer. 3.93e+1. What is the difference between the Taxes (in constant 2015 US$) in Malawi in 2002 and the Taxes (in constant 2015 US$) in Mongolia in 2007?
Offer a terse response. -2.59e+08. What is the difference between the Taxes (in constant 2015 US$) of Egypt, Arab Rep. in 2003 and the Taxes (in constant 2015 US$) of India in 2004?
Provide a succinct answer. -5.49e+1. What is the difference between the Taxes (in constant 2015 US$) of Egypt, Arab Rep. in 2003 and the Taxes (in constant 2015 US$) of Malawi in 2004?
Offer a very short reply. 5.10e+09. What is the difference between the Taxes (in constant 2015 US$) of Egypt, Arab Rep. in 2003 and the Taxes (in constant 2015 US$) of Mongolia in 2004?
Give a very brief answer. 5.11e+09. What is the difference between the Taxes (in constant 2015 US$) in India in 2003 and the Taxes (in constant 2015 US$) in Malawi in 2004?
Offer a terse response. 4.67e+1. What is the difference between the Taxes (in constant 2015 US$) of India in 2003 and the Taxes (in constant 2015 US$) of Mongolia in 2004?
Offer a very short reply. 4.67e+1. What is the difference between the Taxes (in constant 2015 US$) in Malawi in 2003 and the Taxes (in constant 2015 US$) in Mongolia in 2004?
Your answer should be very brief. -7.55e+07. What is the difference between the Taxes (in constant 2015 US$) in Egypt, Arab Rep. in 2003 and the Taxes (in constant 2015 US$) in India in 2005?
Keep it short and to the point. -6.31e+1. What is the difference between the Taxes (in constant 2015 US$) in Egypt, Arab Rep. in 2003 and the Taxes (in constant 2015 US$) in Malawi in 2005?
Give a very brief answer. 5.06e+09. What is the difference between the Taxes (in constant 2015 US$) of Egypt, Arab Rep. in 2003 and the Taxes (in constant 2015 US$) of Mongolia in 2005?
Your answer should be very brief. 5.08e+09. What is the difference between the Taxes (in constant 2015 US$) in India in 2003 and the Taxes (in constant 2015 US$) in Malawi in 2005?
Make the answer very short. 4.67e+1. What is the difference between the Taxes (in constant 2015 US$) in India in 2003 and the Taxes (in constant 2015 US$) in Mongolia in 2005?
Your response must be concise. 4.67e+1. What is the difference between the Taxes (in constant 2015 US$) of Malawi in 2003 and the Taxes (in constant 2015 US$) of Mongolia in 2005?
Offer a very short reply. -1.07e+08. What is the difference between the Taxes (in constant 2015 US$) of Egypt, Arab Rep. in 2003 and the Taxes (in constant 2015 US$) of India in 2006?
Give a very brief answer. -7.01e+1. What is the difference between the Taxes (in constant 2015 US$) in Egypt, Arab Rep. in 2003 and the Taxes (in constant 2015 US$) in Malawi in 2006?
Provide a short and direct response. 5.06e+09. What is the difference between the Taxes (in constant 2015 US$) in Egypt, Arab Rep. in 2003 and the Taxes (in constant 2015 US$) in Mongolia in 2006?
Give a very brief answer. 5.00e+09. What is the difference between the Taxes (in constant 2015 US$) in India in 2003 and the Taxes (in constant 2015 US$) in Malawi in 2006?
Ensure brevity in your answer.  4.67e+1. What is the difference between the Taxes (in constant 2015 US$) of India in 2003 and the Taxes (in constant 2015 US$) of Mongolia in 2006?
Provide a succinct answer. 4.66e+1. What is the difference between the Taxes (in constant 2015 US$) of Malawi in 2003 and the Taxes (in constant 2015 US$) of Mongolia in 2006?
Give a very brief answer. -1.92e+08. What is the difference between the Taxes (in constant 2015 US$) of Egypt, Arab Rep. in 2003 and the Taxes (in constant 2015 US$) of India in 2007?
Give a very brief answer. -9.53e+1. What is the difference between the Taxes (in constant 2015 US$) in Egypt, Arab Rep. in 2003 and the Taxes (in constant 2015 US$) in Malawi in 2007?
Your response must be concise. 5.04e+09. What is the difference between the Taxes (in constant 2015 US$) in Egypt, Arab Rep. in 2003 and the Taxes (in constant 2015 US$) in Mongolia in 2007?
Your answer should be very brief. 4.92e+09. What is the difference between the Taxes (in constant 2015 US$) of India in 2003 and the Taxes (in constant 2015 US$) of Malawi in 2007?
Provide a succinct answer. 4.66e+1. What is the difference between the Taxes (in constant 2015 US$) of India in 2003 and the Taxes (in constant 2015 US$) of Mongolia in 2007?
Keep it short and to the point. 4.65e+1. What is the difference between the Taxes (in constant 2015 US$) of Malawi in 2003 and the Taxes (in constant 2015 US$) of Mongolia in 2007?
Your answer should be very brief. -2.69e+08. What is the difference between the Taxes (in constant 2015 US$) in Egypt, Arab Rep. in 2004 and the Taxes (in constant 2015 US$) in India in 2005?
Provide a succinct answer. -6.37e+1. What is the difference between the Taxes (in constant 2015 US$) of Egypt, Arab Rep. in 2004 and the Taxes (in constant 2015 US$) of Malawi in 2005?
Provide a short and direct response. 4.44e+09. What is the difference between the Taxes (in constant 2015 US$) of Egypt, Arab Rep. in 2004 and the Taxes (in constant 2015 US$) of Mongolia in 2005?
Your response must be concise. 4.46e+09. What is the difference between the Taxes (in constant 2015 US$) of India in 2004 and the Taxes (in constant 2015 US$) of Malawi in 2005?
Keep it short and to the point. 6.00e+1. What is the difference between the Taxes (in constant 2015 US$) in India in 2004 and the Taxes (in constant 2015 US$) in Mongolia in 2005?
Make the answer very short. 6.00e+1. What is the difference between the Taxes (in constant 2015 US$) in Malawi in 2004 and the Taxes (in constant 2015 US$) in Mongolia in 2005?
Your answer should be compact. -1.50e+07. What is the difference between the Taxes (in constant 2015 US$) of Egypt, Arab Rep. in 2004 and the Taxes (in constant 2015 US$) of India in 2006?
Your answer should be very brief. -7.07e+1. What is the difference between the Taxes (in constant 2015 US$) of Egypt, Arab Rep. in 2004 and the Taxes (in constant 2015 US$) of Malawi in 2006?
Your answer should be very brief. 4.44e+09. What is the difference between the Taxes (in constant 2015 US$) of Egypt, Arab Rep. in 2004 and the Taxes (in constant 2015 US$) of Mongolia in 2006?
Your response must be concise. 4.38e+09. What is the difference between the Taxes (in constant 2015 US$) in India in 2004 and the Taxes (in constant 2015 US$) in Malawi in 2006?
Keep it short and to the point. 6.00e+1. What is the difference between the Taxes (in constant 2015 US$) in India in 2004 and the Taxes (in constant 2015 US$) in Mongolia in 2006?
Your answer should be very brief. 5.99e+1. What is the difference between the Taxes (in constant 2015 US$) of Malawi in 2004 and the Taxes (in constant 2015 US$) of Mongolia in 2006?
Give a very brief answer. -9.98e+07. What is the difference between the Taxes (in constant 2015 US$) of Egypt, Arab Rep. in 2004 and the Taxes (in constant 2015 US$) of India in 2007?
Give a very brief answer. -9.59e+1. What is the difference between the Taxes (in constant 2015 US$) of Egypt, Arab Rep. in 2004 and the Taxes (in constant 2015 US$) of Malawi in 2007?
Your answer should be compact. 4.42e+09. What is the difference between the Taxes (in constant 2015 US$) of Egypt, Arab Rep. in 2004 and the Taxes (in constant 2015 US$) of Mongolia in 2007?
Your response must be concise. 4.30e+09. What is the difference between the Taxes (in constant 2015 US$) of India in 2004 and the Taxes (in constant 2015 US$) of Malawi in 2007?
Keep it short and to the point. 6.00e+1. What is the difference between the Taxes (in constant 2015 US$) in India in 2004 and the Taxes (in constant 2015 US$) in Mongolia in 2007?
Keep it short and to the point. 5.98e+1. What is the difference between the Taxes (in constant 2015 US$) of Malawi in 2004 and the Taxes (in constant 2015 US$) of Mongolia in 2007?
Your answer should be very brief. -1.77e+08. What is the difference between the Taxes (in constant 2015 US$) in Egypt, Arab Rep. in 2005 and the Taxes (in constant 2015 US$) in India in 2006?
Provide a short and direct response. -7.01e+1. What is the difference between the Taxes (in constant 2015 US$) in Egypt, Arab Rep. in 2005 and the Taxes (in constant 2015 US$) in Malawi in 2006?
Your answer should be very brief. 5.05e+09. What is the difference between the Taxes (in constant 2015 US$) in Egypt, Arab Rep. in 2005 and the Taxes (in constant 2015 US$) in Mongolia in 2006?
Offer a terse response. 4.98e+09. What is the difference between the Taxes (in constant 2015 US$) of India in 2005 and the Taxes (in constant 2015 US$) of Malawi in 2006?
Your answer should be very brief. 6.81e+1. What is the difference between the Taxes (in constant 2015 US$) of India in 2005 and the Taxes (in constant 2015 US$) of Mongolia in 2006?
Your answer should be very brief. 6.81e+1. What is the difference between the Taxes (in constant 2015 US$) of Malawi in 2005 and the Taxes (in constant 2015 US$) of Mongolia in 2006?
Keep it short and to the point. -6.09e+07. What is the difference between the Taxes (in constant 2015 US$) in Egypt, Arab Rep. in 2005 and the Taxes (in constant 2015 US$) in India in 2007?
Your answer should be very brief. -9.53e+1. What is the difference between the Taxes (in constant 2015 US$) of Egypt, Arab Rep. in 2005 and the Taxes (in constant 2015 US$) of Malawi in 2007?
Offer a very short reply. 5.03e+09. What is the difference between the Taxes (in constant 2015 US$) in Egypt, Arab Rep. in 2005 and the Taxes (in constant 2015 US$) in Mongolia in 2007?
Give a very brief answer. 4.91e+09. What is the difference between the Taxes (in constant 2015 US$) of India in 2005 and the Taxes (in constant 2015 US$) of Malawi in 2007?
Offer a terse response. 6.81e+1. What is the difference between the Taxes (in constant 2015 US$) in India in 2005 and the Taxes (in constant 2015 US$) in Mongolia in 2007?
Make the answer very short. 6.80e+1. What is the difference between the Taxes (in constant 2015 US$) in Malawi in 2005 and the Taxes (in constant 2015 US$) in Mongolia in 2007?
Provide a short and direct response. -1.38e+08. What is the difference between the Taxes (in constant 2015 US$) in Egypt, Arab Rep. in 2006 and the Taxes (in constant 2015 US$) in India in 2007?
Provide a short and direct response. -9.42e+1. What is the difference between the Taxes (in constant 2015 US$) in Egypt, Arab Rep. in 2006 and the Taxes (in constant 2015 US$) in Malawi in 2007?
Keep it short and to the point. 6.07e+09. What is the difference between the Taxes (in constant 2015 US$) in Egypt, Arab Rep. in 2006 and the Taxes (in constant 2015 US$) in Mongolia in 2007?
Ensure brevity in your answer.  5.95e+09. What is the difference between the Taxes (in constant 2015 US$) in India in 2006 and the Taxes (in constant 2015 US$) in Malawi in 2007?
Offer a very short reply. 7.52e+1. What is the difference between the Taxes (in constant 2015 US$) in India in 2006 and the Taxes (in constant 2015 US$) in Mongolia in 2007?
Offer a terse response. 7.50e+1. What is the difference between the Taxes (in constant 2015 US$) in Malawi in 2006 and the Taxes (in constant 2015 US$) in Mongolia in 2007?
Make the answer very short. -1.39e+08. What is the average Taxes (in constant 2015 US$) of Egypt, Arab Rep. per year?
Offer a very short reply. 5.96e+09. What is the average Taxes (in constant 2015 US$) of India per year?
Offer a very short reply. 5.85e+1. What is the average Taxes (in constant 2015 US$) of Malawi per year?
Your response must be concise. 2.19e+08. What is the average Taxes (in constant 2015 US$) of Mongolia per year?
Your answer should be very brief. 2.36e+08. In the year 2000, what is the difference between the Taxes (in constant 2015 US$) in Egypt, Arab Rep. and Taxes (in constant 2015 US$) in India?
Provide a succinct answer. -3.15e+1. In the year 2000, what is the difference between the Taxes (in constant 2015 US$) in Egypt, Arab Rep. and Taxes (in constant 2015 US$) in Malawi?
Your answer should be compact. 7.00e+09. In the year 2000, what is the difference between the Taxes (in constant 2015 US$) in Egypt, Arab Rep. and Taxes (in constant 2015 US$) in Mongolia?
Keep it short and to the point. 7.05e+09. In the year 2000, what is the difference between the Taxes (in constant 2015 US$) in India and Taxes (in constant 2015 US$) in Malawi?
Give a very brief answer. 3.85e+1. In the year 2000, what is the difference between the Taxes (in constant 2015 US$) in India and Taxes (in constant 2015 US$) in Mongolia?
Offer a very short reply. 3.85e+1. In the year 2000, what is the difference between the Taxes (in constant 2015 US$) of Malawi and Taxes (in constant 2015 US$) of Mongolia?
Your answer should be compact. 4.39e+07. In the year 2001, what is the difference between the Taxes (in constant 2015 US$) in Egypt, Arab Rep. and Taxes (in constant 2015 US$) in India?
Your answer should be very brief. -3.07e+1. In the year 2001, what is the difference between the Taxes (in constant 2015 US$) of Egypt, Arab Rep. and Taxes (in constant 2015 US$) of Malawi?
Provide a short and direct response. 6.96e+09. In the year 2001, what is the difference between the Taxes (in constant 2015 US$) of Egypt, Arab Rep. and Taxes (in constant 2015 US$) of Mongolia?
Give a very brief answer. 6.96e+09. In the year 2001, what is the difference between the Taxes (in constant 2015 US$) in India and Taxes (in constant 2015 US$) in Malawi?
Offer a very short reply. 3.77e+1. In the year 2001, what is the difference between the Taxes (in constant 2015 US$) in India and Taxes (in constant 2015 US$) in Mongolia?
Make the answer very short. 3.77e+1. In the year 2001, what is the difference between the Taxes (in constant 2015 US$) in Malawi and Taxes (in constant 2015 US$) in Mongolia?
Make the answer very short. -7.84e+06. In the year 2002, what is the difference between the Taxes (in constant 2015 US$) in Egypt, Arab Rep. and Taxes (in constant 2015 US$) in India?
Offer a terse response. -3.41e+1. In the year 2002, what is the difference between the Taxes (in constant 2015 US$) of Egypt, Arab Rep. and Taxes (in constant 2015 US$) of Malawi?
Offer a terse response. 5.48e+09. In the year 2002, what is the difference between the Taxes (in constant 2015 US$) of Egypt, Arab Rep. and Taxes (in constant 2015 US$) of Mongolia?
Give a very brief answer. 5.47e+09. In the year 2002, what is the difference between the Taxes (in constant 2015 US$) in India and Taxes (in constant 2015 US$) in Malawi?
Your answer should be compact. 3.96e+1. In the year 2002, what is the difference between the Taxes (in constant 2015 US$) in India and Taxes (in constant 2015 US$) in Mongolia?
Provide a short and direct response. 3.96e+1. In the year 2002, what is the difference between the Taxes (in constant 2015 US$) in Malawi and Taxes (in constant 2015 US$) in Mongolia?
Your answer should be very brief. -6.00e+06. In the year 2003, what is the difference between the Taxes (in constant 2015 US$) of Egypt, Arab Rep. and Taxes (in constant 2015 US$) of India?
Offer a very short reply. -4.16e+1. In the year 2003, what is the difference between the Taxes (in constant 2015 US$) of Egypt, Arab Rep. and Taxes (in constant 2015 US$) of Malawi?
Your answer should be very brief. 5.19e+09. In the year 2003, what is the difference between the Taxes (in constant 2015 US$) of Egypt, Arab Rep. and Taxes (in constant 2015 US$) of Mongolia?
Ensure brevity in your answer.  5.16e+09. In the year 2003, what is the difference between the Taxes (in constant 2015 US$) in India and Taxes (in constant 2015 US$) in Malawi?
Offer a terse response. 4.68e+1. In the year 2003, what is the difference between the Taxes (in constant 2015 US$) in India and Taxes (in constant 2015 US$) in Mongolia?
Your response must be concise. 4.68e+1. In the year 2003, what is the difference between the Taxes (in constant 2015 US$) in Malawi and Taxes (in constant 2015 US$) in Mongolia?
Your response must be concise. -2.68e+07. In the year 2004, what is the difference between the Taxes (in constant 2015 US$) in Egypt, Arab Rep. and Taxes (in constant 2015 US$) in India?
Offer a terse response. -5.55e+1. In the year 2004, what is the difference between the Taxes (in constant 2015 US$) of Egypt, Arab Rep. and Taxes (in constant 2015 US$) of Malawi?
Keep it short and to the point. 4.48e+09. In the year 2004, what is the difference between the Taxes (in constant 2015 US$) of Egypt, Arab Rep. and Taxes (in constant 2015 US$) of Mongolia?
Provide a short and direct response. 4.49e+09. In the year 2004, what is the difference between the Taxes (in constant 2015 US$) in India and Taxes (in constant 2015 US$) in Malawi?
Ensure brevity in your answer.  6.00e+1. In the year 2004, what is the difference between the Taxes (in constant 2015 US$) of India and Taxes (in constant 2015 US$) of Mongolia?
Provide a short and direct response. 6.00e+1. In the year 2004, what is the difference between the Taxes (in constant 2015 US$) in Malawi and Taxes (in constant 2015 US$) in Mongolia?
Keep it short and to the point. 1.65e+07. In the year 2005, what is the difference between the Taxes (in constant 2015 US$) of Egypt, Arab Rep. and Taxes (in constant 2015 US$) of India?
Ensure brevity in your answer.  -6.31e+1. In the year 2005, what is the difference between the Taxes (in constant 2015 US$) of Egypt, Arab Rep. and Taxes (in constant 2015 US$) of Malawi?
Offer a very short reply. 5.05e+09. In the year 2005, what is the difference between the Taxes (in constant 2015 US$) of Egypt, Arab Rep. and Taxes (in constant 2015 US$) of Mongolia?
Ensure brevity in your answer.  5.07e+09. In the year 2005, what is the difference between the Taxes (in constant 2015 US$) of India and Taxes (in constant 2015 US$) of Malawi?
Provide a short and direct response. 6.81e+1. In the year 2005, what is the difference between the Taxes (in constant 2015 US$) in India and Taxes (in constant 2015 US$) in Mongolia?
Give a very brief answer. 6.81e+1. In the year 2005, what is the difference between the Taxes (in constant 2015 US$) in Malawi and Taxes (in constant 2015 US$) in Mongolia?
Provide a short and direct response. 2.40e+07. In the year 2006, what is the difference between the Taxes (in constant 2015 US$) of Egypt, Arab Rep. and Taxes (in constant 2015 US$) of India?
Your answer should be very brief. -6.91e+1. In the year 2006, what is the difference between the Taxes (in constant 2015 US$) of Egypt, Arab Rep. and Taxes (in constant 2015 US$) of Malawi?
Make the answer very short. 6.09e+09. In the year 2006, what is the difference between the Taxes (in constant 2015 US$) of Egypt, Arab Rep. and Taxes (in constant 2015 US$) of Mongolia?
Ensure brevity in your answer.  6.03e+09. In the year 2006, what is the difference between the Taxes (in constant 2015 US$) in India and Taxes (in constant 2015 US$) in Malawi?
Your answer should be very brief. 7.52e+1. In the year 2006, what is the difference between the Taxes (in constant 2015 US$) in India and Taxes (in constant 2015 US$) in Mongolia?
Provide a short and direct response. 7.51e+1. In the year 2006, what is the difference between the Taxes (in constant 2015 US$) in Malawi and Taxes (in constant 2015 US$) in Mongolia?
Give a very brief answer. -6.19e+07. In the year 2007, what is the difference between the Taxes (in constant 2015 US$) of Egypt, Arab Rep. and Taxes (in constant 2015 US$) of India?
Keep it short and to the point. -9.46e+1. In the year 2007, what is the difference between the Taxes (in constant 2015 US$) in Egypt, Arab Rep. and Taxes (in constant 2015 US$) in Malawi?
Your answer should be very brief. 5.72e+09. In the year 2007, what is the difference between the Taxes (in constant 2015 US$) of Egypt, Arab Rep. and Taxes (in constant 2015 US$) of Mongolia?
Provide a succinct answer. 5.61e+09. In the year 2007, what is the difference between the Taxes (in constant 2015 US$) in India and Taxes (in constant 2015 US$) in Malawi?
Offer a very short reply. 1.00e+11. In the year 2007, what is the difference between the Taxes (in constant 2015 US$) of India and Taxes (in constant 2015 US$) of Mongolia?
Your answer should be compact. 1.00e+11. In the year 2007, what is the difference between the Taxes (in constant 2015 US$) of Malawi and Taxes (in constant 2015 US$) of Mongolia?
Make the answer very short. -1.18e+08. What is the ratio of the Taxes (in constant 2015 US$) of Egypt, Arab Rep. in 2000 to that in 2001?
Your response must be concise. 1.01. What is the ratio of the Taxes (in constant 2015 US$) of India in 2000 to that in 2001?
Your answer should be very brief. 1.02. What is the ratio of the Taxes (in constant 2015 US$) of Malawi in 2000 to that in 2001?
Keep it short and to the point. 1.1. What is the ratio of the Taxes (in constant 2015 US$) in Mongolia in 2000 to that in 2001?
Make the answer very short. 0.78. What is the ratio of the Taxes (in constant 2015 US$) of Egypt, Arab Rep. in 2000 to that in 2002?
Provide a short and direct response. 1.27. What is the ratio of the Taxes (in constant 2015 US$) of India in 2000 to that in 2002?
Your response must be concise. 0.97. What is the ratio of the Taxes (in constant 2015 US$) in Malawi in 2000 to that in 2002?
Give a very brief answer. 1.06. What is the ratio of the Taxes (in constant 2015 US$) of Mongolia in 2000 to that in 2002?
Offer a terse response. 0.76. What is the ratio of the Taxes (in constant 2015 US$) of Egypt, Arab Rep. in 2000 to that in 2003?
Provide a succinct answer. 1.34. What is the ratio of the Taxes (in constant 2015 US$) of India in 2000 to that in 2003?
Offer a very short reply. 0.82. What is the ratio of the Taxes (in constant 2015 US$) of Malawi in 2000 to that in 2003?
Provide a succinct answer. 1.13. What is the ratio of the Taxes (in constant 2015 US$) in Mongolia in 2000 to that in 2003?
Ensure brevity in your answer.  0.71. What is the ratio of the Taxes (in constant 2015 US$) in Egypt, Arab Rep. in 2000 to that in 2004?
Ensure brevity in your answer.  1.52. What is the ratio of the Taxes (in constant 2015 US$) of India in 2000 to that in 2004?
Offer a terse response. 0.64. What is the ratio of the Taxes (in constant 2015 US$) of Malawi in 2000 to that in 2004?
Provide a succinct answer. 0.7. What is the ratio of the Taxes (in constant 2015 US$) in Mongolia in 2000 to that in 2004?
Give a very brief answer. 0.56. What is the ratio of the Taxes (in constant 2015 US$) of Egypt, Arab Rep. in 2000 to that in 2005?
Make the answer very short. 1.35. What is the ratio of the Taxes (in constant 2015 US$) of India in 2000 to that in 2005?
Offer a terse response. 0.57. What is the ratio of the Taxes (in constant 2015 US$) of Malawi in 2000 to that in 2005?
Ensure brevity in your answer.  0.61. What is the ratio of the Taxes (in constant 2015 US$) in Mongolia in 2000 to that in 2005?
Your answer should be very brief. 0.49. What is the ratio of the Taxes (in constant 2015 US$) of Egypt, Arab Rep. in 2000 to that in 2006?
Offer a very short reply. 1.13. What is the ratio of the Taxes (in constant 2015 US$) in India in 2000 to that in 2006?
Your answer should be compact. 0.51. What is the ratio of the Taxes (in constant 2015 US$) of Malawi in 2000 to that in 2006?
Offer a very short reply. 0.61. What is the ratio of the Taxes (in constant 2015 US$) in Mongolia in 2000 to that in 2006?
Your answer should be very brief. 0.37. What is the ratio of the Taxes (in constant 2015 US$) of Egypt, Arab Rep. in 2000 to that in 2007?
Your answer should be very brief. 1.19. What is the ratio of the Taxes (in constant 2015 US$) in India in 2000 to that in 2007?
Make the answer very short. 0.38. What is the ratio of the Taxes (in constant 2015 US$) in Malawi in 2000 to that in 2007?
Keep it short and to the point. 0.57. What is the ratio of the Taxes (in constant 2015 US$) of Mongolia in 2000 to that in 2007?
Provide a succinct answer. 0.3. What is the ratio of the Taxes (in constant 2015 US$) in Egypt, Arab Rep. in 2001 to that in 2002?
Keep it short and to the point. 1.26. What is the ratio of the Taxes (in constant 2015 US$) of India in 2001 to that in 2002?
Offer a terse response. 0.95. What is the ratio of the Taxes (in constant 2015 US$) of Malawi in 2001 to that in 2002?
Ensure brevity in your answer.  0.96. What is the ratio of the Taxes (in constant 2015 US$) in Mongolia in 2001 to that in 2002?
Provide a succinct answer. 0.97. What is the ratio of the Taxes (in constant 2015 US$) of Egypt, Arab Rep. in 2001 to that in 2003?
Keep it short and to the point. 1.33. What is the ratio of the Taxes (in constant 2015 US$) of India in 2001 to that in 2003?
Provide a succinct answer. 0.81. What is the ratio of the Taxes (in constant 2015 US$) in Malawi in 2001 to that in 2003?
Give a very brief answer. 1.02. What is the ratio of the Taxes (in constant 2015 US$) of Mongolia in 2001 to that in 2003?
Your answer should be compact. 0.91. What is the ratio of the Taxes (in constant 2015 US$) of Egypt, Arab Rep. in 2001 to that in 2004?
Offer a very short reply. 1.51. What is the ratio of the Taxes (in constant 2015 US$) in India in 2001 to that in 2004?
Keep it short and to the point. 0.63. What is the ratio of the Taxes (in constant 2015 US$) in Malawi in 2001 to that in 2004?
Offer a very short reply. 0.64. What is the ratio of the Taxes (in constant 2015 US$) of Mongolia in 2001 to that in 2004?
Ensure brevity in your answer.  0.72. What is the ratio of the Taxes (in constant 2015 US$) in Egypt, Arab Rep. in 2001 to that in 2005?
Your answer should be very brief. 1.34. What is the ratio of the Taxes (in constant 2015 US$) in India in 2001 to that in 2005?
Your answer should be compact. 0.55. What is the ratio of the Taxes (in constant 2015 US$) of Malawi in 2001 to that in 2005?
Provide a short and direct response. 0.55. What is the ratio of the Taxes (in constant 2015 US$) in Mongolia in 2001 to that in 2005?
Your response must be concise. 0.63. What is the ratio of the Taxes (in constant 2015 US$) in Egypt, Arab Rep. in 2001 to that in 2006?
Provide a succinct answer. 1.12. What is the ratio of the Taxes (in constant 2015 US$) of India in 2001 to that in 2006?
Your answer should be compact. 0.5. What is the ratio of the Taxes (in constant 2015 US$) in Malawi in 2001 to that in 2006?
Your answer should be compact. 0.55. What is the ratio of the Taxes (in constant 2015 US$) in Mongolia in 2001 to that in 2006?
Ensure brevity in your answer.  0.47. What is the ratio of the Taxes (in constant 2015 US$) in Egypt, Arab Rep. in 2001 to that in 2007?
Ensure brevity in your answer.  1.18. What is the ratio of the Taxes (in constant 2015 US$) of India in 2001 to that in 2007?
Make the answer very short. 0.38. What is the ratio of the Taxes (in constant 2015 US$) in Malawi in 2001 to that in 2007?
Offer a very short reply. 0.51. What is the ratio of the Taxes (in constant 2015 US$) of Mongolia in 2001 to that in 2007?
Your answer should be very brief. 0.39. What is the ratio of the Taxes (in constant 2015 US$) in Egypt, Arab Rep. in 2002 to that in 2003?
Offer a very short reply. 1.06. What is the ratio of the Taxes (in constant 2015 US$) of India in 2002 to that in 2003?
Offer a terse response. 0.85. What is the ratio of the Taxes (in constant 2015 US$) in Malawi in 2002 to that in 2003?
Provide a short and direct response. 1.07. What is the ratio of the Taxes (in constant 2015 US$) of Mongolia in 2002 to that in 2003?
Keep it short and to the point. 0.94. What is the ratio of the Taxes (in constant 2015 US$) of Egypt, Arab Rep. in 2002 to that in 2004?
Make the answer very short. 1.2. What is the ratio of the Taxes (in constant 2015 US$) of India in 2002 to that in 2004?
Provide a short and direct response. 0.66. What is the ratio of the Taxes (in constant 2015 US$) in Malawi in 2002 to that in 2004?
Keep it short and to the point. 0.66. What is the ratio of the Taxes (in constant 2015 US$) in Mongolia in 2002 to that in 2004?
Give a very brief answer. 0.74. What is the ratio of the Taxes (in constant 2015 US$) of Egypt, Arab Rep. in 2002 to that in 2005?
Keep it short and to the point. 1.06. What is the ratio of the Taxes (in constant 2015 US$) of India in 2002 to that in 2005?
Offer a terse response. 0.58. What is the ratio of the Taxes (in constant 2015 US$) of Malawi in 2002 to that in 2005?
Your answer should be compact. 0.57. What is the ratio of the Taxes (in constant 2015 US$) in Mongolia in 2002 to that in 2005?
Offer a terse response. 0.65. What is the ratio of the Taxes (in constant 2015 US$) of Egypt, Arab Rep. in 2002 to that in 2006?
Ensure brevity in your answer.  0.89. What is the ratio of the Taxes (in constant 2015 US$) in India in 2002 to that in 2006?
Offer a terse response. 0.53. What is the ratio of the Taxes (in constant 2015 US$) of Malawi in 2002 to that in 2006?
Make the answer very short. 0.57. What is the ratio of the Taxes (in constant 2015 US$) of Mongolia in 2002 to that in 2006?
Provide a succinct answer. 0.49. What is the ratio of the Taxes (in constant 2015 US$) of Egypt, Arab Rep. in 2002 to that in 2007?
Offer a very short reply. 0.94. What is the ratio of the Taxes (in constant 2015 US$) of India in 2002 to that in 2007?
Keep it short and to the point. 0.4. What is the ratio of the Taxes (in constant 2015 US$) of Malawi in 2002 to that in 2007?
Give a very brief answer. 0.53. What is the ratio of the Taxes (in constant 2015 US$) of Mongolia in 2002 to that in 2007?
Keep it short and to the point. 0.4. What is the ratio of the Taxes (in constant 2015 US$) in Egypt, Arab Rep. in 2003 to that in 2004?
Ensure brevity in your answer.  1.13. What is the ratio of the Taxes (in constant 2015 US$) in India in 2003 to that in 2004?
Provide a short and direct response. 0.78. What is the ratio of the Taxes (in constant 2015 US$) of Malawi in 2003 to that in 2004?
Your answer should be compact. 0.62. What is the ratio of the Taxes (in constant 2015 US$) of Mongolia in 2003 to that in 2004?
Provide a succinct answer. 0.79. What is the ratio of the Taxes (in constant 2015 US$) in Egypt, Arab Rep. in 2003 to that in 2005?
Your response must be concise. 1. What is the ratio of the Taxes (in constant 2015 US$) of India in 2003 to that in 2005?
Provide a short and direct response. 0.69. What is the ratio of the Taxes (in constant 2015 US$) in Malawi in 2003 to that in 2005?
Offer a terse response. 0.54. What is the ratio of the Taxes (in constant 2015 US$) in Mongolia in 2003 to that in 2005?
Your answer should be very brief. 0.69. What is the ratio of the Taxes (in constant 2015 US$) of Egypt, Arab Rep. in 2003 to that in 2006?
Your answer should be compact. 0.84. What is the ratio of the Taxes (in constant 2015 US$) of India in 2003 to that in 2006?
Make the answer very short. 0.62. What is the ratio of the Taxes (in constant 2015 US$) of Malawi in 2003 to that in 2006?
Give a very brief answer. 0.54. What is the ratio of the Taxes (in constant 2015 US$) in Mongolia in 2003 to that in 2006?
Provide a succinct answer. 0.52. What is the ratio of the Taxes (in constant 2015 US$) of Egypt, Arab Rep. in 2003 to that in 2007?
Offer a terse response. 0.89. What is the ratio of the Taxes (in constant 2015 US$) in India in 2003 to that in 2007?
Keep it short and to the point. 0.47. What is the ratio of the Taxes (in constant 2015 US$) of Malawi in 2003 to that in 2007?
Your response must be concise. 0.5. What is the ratio of the Taxes (in constant 2015 US$) in Mongolia in 2003 to that in 2007?
Offer a terse response. 0.42. What is the ratio of the Taxes (in constant 2015 US$) in Egypt, Arab Rep. in 2004 to that in 2005?
Ensure brevity in your answer.  0.89. What is the ratio of the Taxes (in constant 2015 US$) in India in 2004 to that in 2005?
Your answer should be compact. 0.88. What is the ratio of the Taxes (in constant 2015 US$) of Malawi in 2004 to that in 2005?
Your answer should be very brief. 0.86. What is the ratio of the Taxes (in constant 2015 US$) of Mongolia in 2004 to that in 2005?
Provide a succinct answer. 0.88. What is the ratio of the Taxes (in constant 2015 US$) of Egypt, Arab Rep. in 2004 to that in 2006?
Give a very brief answer. 0.74. What is the ratio of the Taxes (in constant 2015 US$) in India in 2004 to that in 2006?
Provide a succinct answer. 0.8. What is the ratio of the Taxes (in constant 2015 US$) in Malawi in 2004 to that in 2006?
Your answer should be very brief. 0.87. What is the ratio of the Taxes (in constant 2015 US$) of Mongolia in 2004 to that in 2006?
Offer a terse response. 0.66. What is the ratio of the Taxes (in constant 2015 US$) in Egypt, Arab Rep. in 2004 to that in 2007?
Your answer should be very brief. 0.78. What is the ratio of the Taxes (in constant 2015 US$) of India in 2004 to that in 2007?
Give a very brief answer. 0.6. What is the ratio of the Taxes (in constant 2015 US$) of Malawi in 2004 to that in 2007?
Make the answer very short. 0.81. What is the ratio of the Taxes (in constant 2015 US$) of Mongolia in 2004 to that in 2007?
Ensure brevity in your answer.  0.54. What is the ratio of the Taxes (in constant 2015 US$) in Egypt, Arab Rep. in 2005 to that in 2006?
Your answer should be very brief. 0.84. What is the ratio of the Taxes (in constant 2015 US$) of India in 2005 to that in 2006?
Your response must be concise. 0.91. What is the ratio of the Taxes (in constant 2015 US$) in Malawi in 2005 to that in 2006?
Your response must be concise. 1. What is the ratio of the Taxes (in constant 2015 US$) in Mongolia in 2005 to that in 2006?
Keep it short and to the point. 0.75. What is the ratio of the Taxes (in constant 2015 US$) of Egypt, Arab Rep. in 2005 to that in 2007?
Keep it short and to the point. 0.88. What is the ratio of the Taxes (in constant 2015 US$) of India in 2005 to that in 2007?
Your answer should be compact. 0.68. What is the ratio of the Taxes (in constant 2015 US$) of Malawi in 2005 to that in 2007?
Make the answer very short. 0.94. What is the ratio of the Taxes (in constant 2015 US$) in Mongolia in 2005 to that in 2007?
Your answer should be very brief. 0.62. What is the ratio of the Taxes (in constant 2015 US$) of Egypt, Arab Rep. in 2006 to that in 2007?
Offer a very short reply. 1.06. What is the ratio of the Taxes (in constant 2015 US$) of India in 2006 to that in 2007?
Offer a very short reply. 0.75. What is the ratio of the Taxes (in constant 2015 US$) in Malawi in 2006 to that in 2007?
Your answer should be compact. 0.93. What is the ratio of the Taxes (in constant 2015 US$) in Mongolia in 2006 to that in 2007?
Your response must be concise. 0.82. What is the difference between the highest and the second highest Taxes (in constant 2015 US$) in Egypt, Arab Rep.?
Your answer should be compact. 5.32e+07. What is the difference between the highest and the second highest Taxes (in constant 2015 US$) of India?
Your answer should be compact. 2.51e+1. What is the difference between the highest and the second highest Taxes (in constant 2015 US$) of Malawi?
Keep it short and to the point. 1.95e+07. What is the difference between the highest and the second highest Taxes (in constant 2015 US$) of Mongolia?
Offer a very short reply. 7.67e+07. What is the difference between the highest and the lowest Taxes (in constant 2015 US$) of Egypt, Arab Rep.?
Your answer should be compact. 2.45e+09. What is the difference between the highest and the lowest Taxes (in constant 2015 US$) in India?
Make the answer very short. 6.27e+1. What is the difference between the highest and the lowest Taxes (in constant 2015 US$) in Malawi?
Keep it short and to the point. 1.51e+08. What is the difference between the highest and the lowest Taxes (in constant 2015 US$) in Mongolia?
Provide a short and direct response. 2.93e+08. 